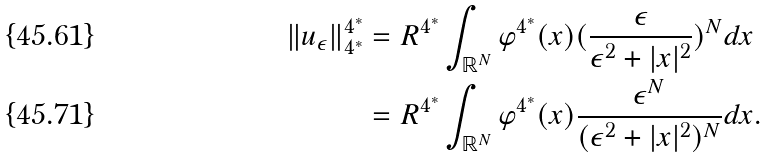Convert formula to latex. <formula><loc_0><loc_0><loc_500><loc_500>\| u _ { \epsilon } \| _ { 4 ^ { * } } ^ { 4 ^ { * } } & = R ^ { 4 ^ { * } } \int _ { \mathbb { R } ^ { N } } \varphi ^ { 4 ^ { * } } ( x ) ( \frac { \epsilon } { \epsilon ^ { 2 } + | x | ^ { 2 } } ) ^ { N } d x \\ & = R ^ { 4 ^ { * } } \int _ { \mathbb { R } ^ { N } } \varphi ^ { 4 ^ { * } } ( x ) \frac { \epsilon ^ { N } } { ( \epsilon ^ { 2 } + | x | ^ { 2 } ) ^ { N } } d x .</formula> 